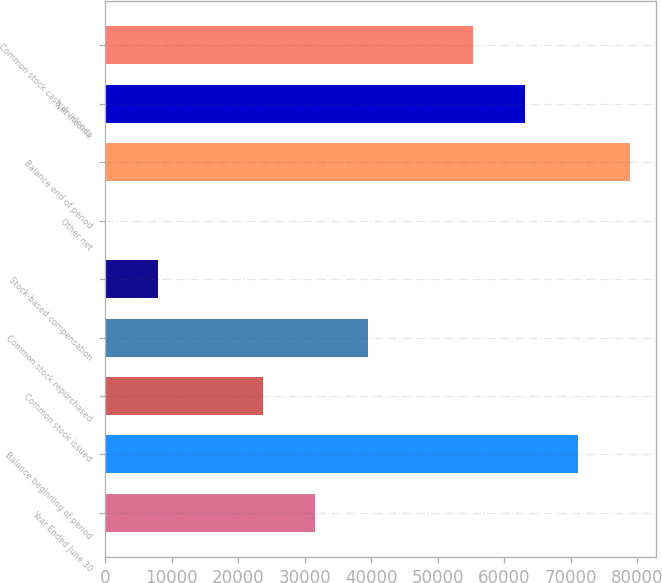<chart> <loc_0><loc_0><loc_500><loc_500><bar_chart><fcel>Year Ended June 30<fcel>Balance beginning of period<fcel>Common stock issued<fcel>Common stock repurchased<fcel>Stock-based compensation<fcel>Other net<fcel>Balance end of period<fcel>Net income<fcel>Common stock cash dividends<nl><fcel>31581.8<fcel>71050.3<fcel>23688.1<fcel>39475.5<fcel>7900.7<fcel>7<fcel>78944<fcel>63156.6<fcel>55262.9<nl></chart> 